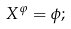Convert formula to latex. <formula><loc_0><loc_0><loc_500><loc_500>X ^ { \varphi } = \phi ;</formula> 